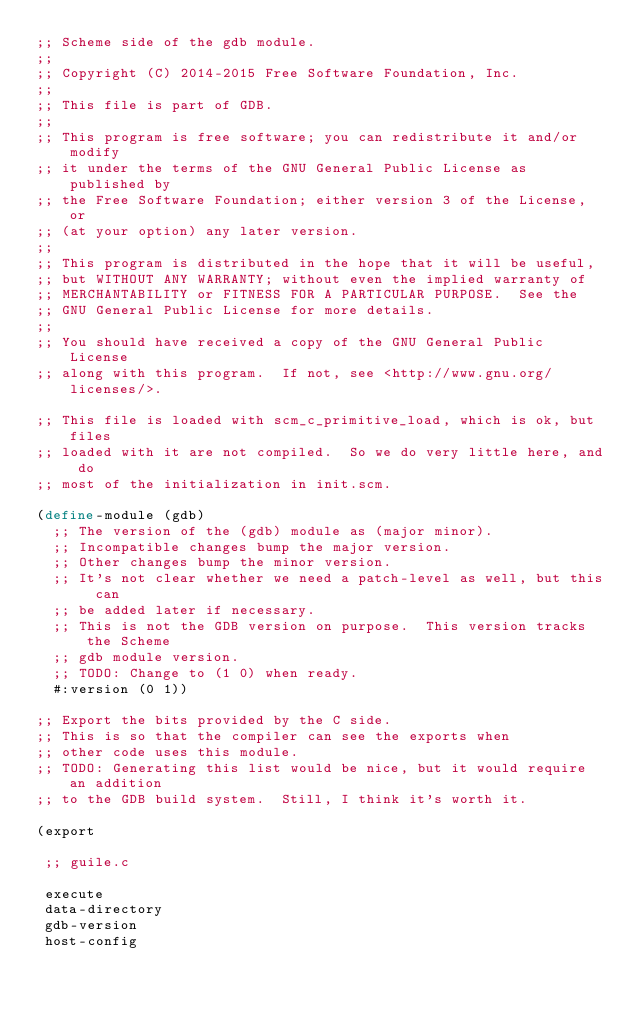Convert code to text. <code><loc_0><loc_0><loc_500><loc_500><_Scheme_>;; Scheme side of the gdb module.
;;
;; Copyright (C) 2014-2015 Free Software Foundation, Inc.
;;
;; This file is part of GDB.
;;
;; This program is free software; you can redistribute it and/or modify
;; it under the terms of the GNU General Public License as published by
;; the Free Software Foundation; either version 3 of the License, or
;; (at your option) any later version.
;;
;; This program is distributed in the hope that it will be useful,
;; but WITHOUT ANY WARRANTY; without even the implied warranty of
;; MERCHANTABILITY or FITNESS FOR A PARTICULAR PURPOSE.  See the
;; GNU General Public License for more details.
;;
;; You should have received a copy of the GNU General Public License
;; along with this program.  If not, see <http://www.gnu.org/licenses/>.

;; This file is loaded with scm_c_primitive_load, which is ok, but files
;; loaded with it are not compiled.  So we do very little here, and do
;; most of the initialization in init.scm.

(define-module (gdb)
  ;; The version of the (gdb) module as (major minor).
  ;; Incompatible changes bump the major version.
  ;; Other changes bump the minor version.
  ;; It's not clear whether we need a patch-level as well, but this can
  ;; be added later if necessary.
  ;; This is not the GDB version on purpose.  This version tracks the Scheme
  ;; gdb module version.
  ;; TODO: Change to (1 0) when ready.
  #:version (0 1))

;; Export the bits provided by the C side.
;; This is so that the compiler can see the exports when
;; other code uses this module.
;; TODO: Generating this list would be nice, but it would require an addition
;; to the GDB build system.  Still, I think it's worth it.

(export

 ;; guile.c

 execute
 data-directory
 gdb-version
 host-config</code> 